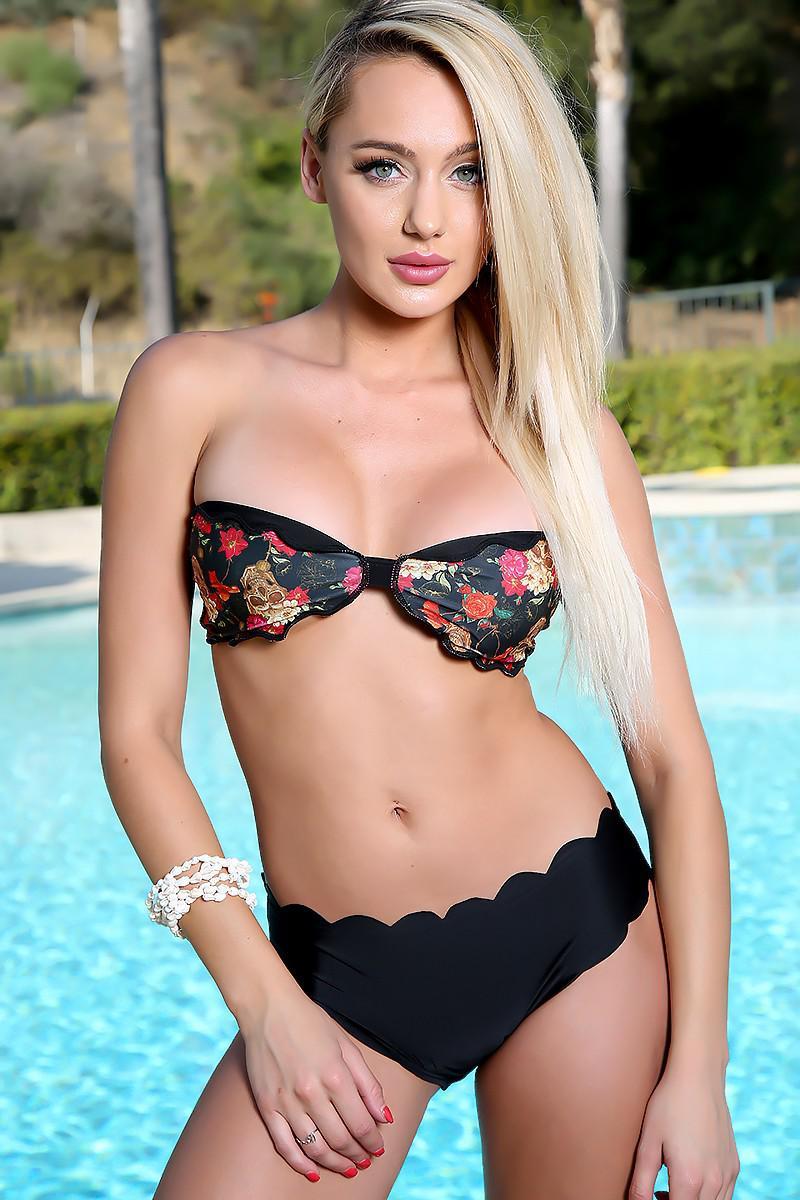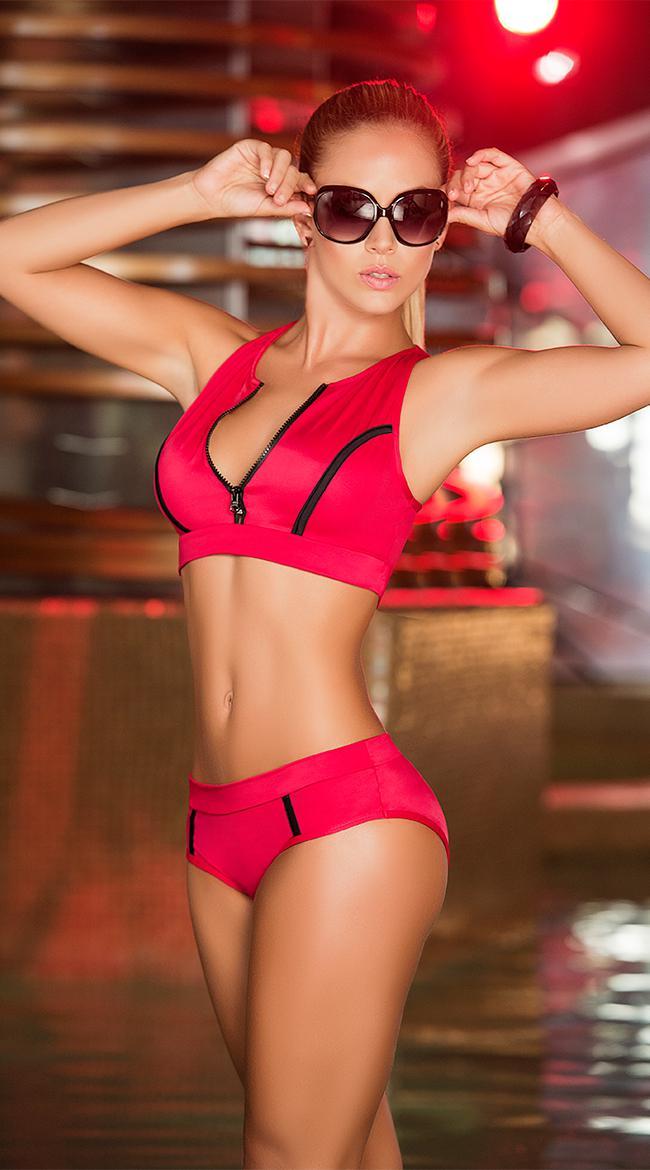The first image is the image on the left, the second image is the image on the right. For the images shown, is this caption "In the left image, the swimsuit top does not match the bottom." true? Answer yes or no. Yes. 